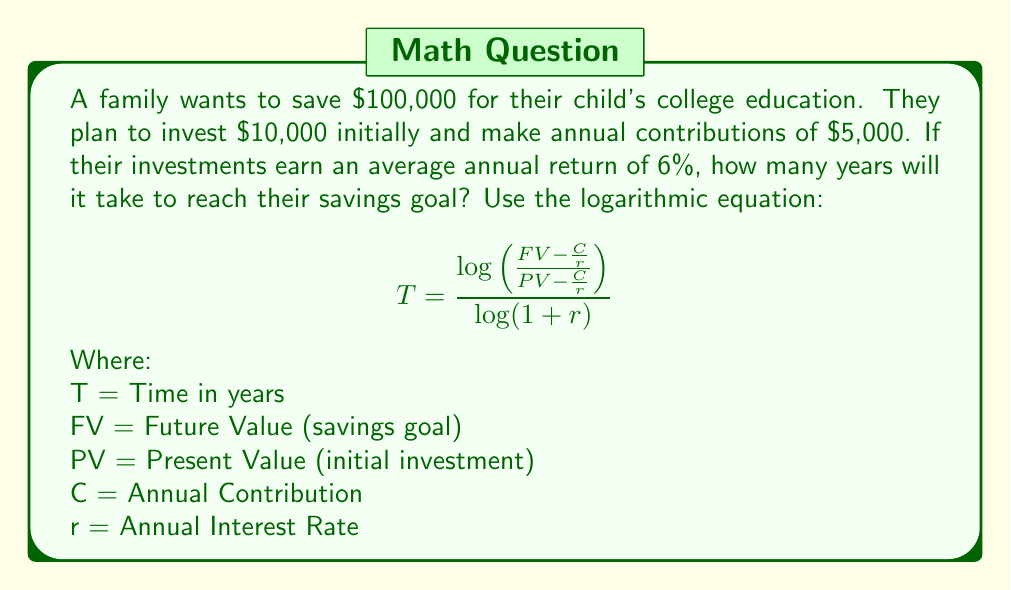Teach me how to tackle this problem. To solve this problem, we'll use the given logarithmic equation and plug in the known values:

FV = $100,000 (savings goal)
PV = $10,000 (initial investment)
C = $5,000 (annual contribution)
r = 0.06 (6% annual return)

Step 1: Substitute the values into the equation:

$$T = \frac{\log(\frac{100,000 - \frac{5,000}{0.06}}{10,000 - \frac{5,000}{0.06}})}{\log(1 + 0.06)}$$

Step 2: Simplify the fractions inside the logarithm:

$$T = \frac{\log(\frac{100,000 - 83,333.33}{10,000 - 83,333.33})}{\log(1.06)}$$

Step 3: Perform the subtractions:

$$T = \frac{\log(\frac{16,666.67}{-73,333.33})}{\log(1.06)}$$

Step 4: Simplify the fraction inside the logarithm:

$$T = \frac{\log(-0.2273)}{\log(1.06)}$$

Step 5: Use a calculator to evaluate the logarithms:

$$T = \frac{-0.6435}{0.0253} \approx 25.43$$

Step 6: Round to the nearest whole number of years:

T ≈ 25 years
Answer: 25 years 